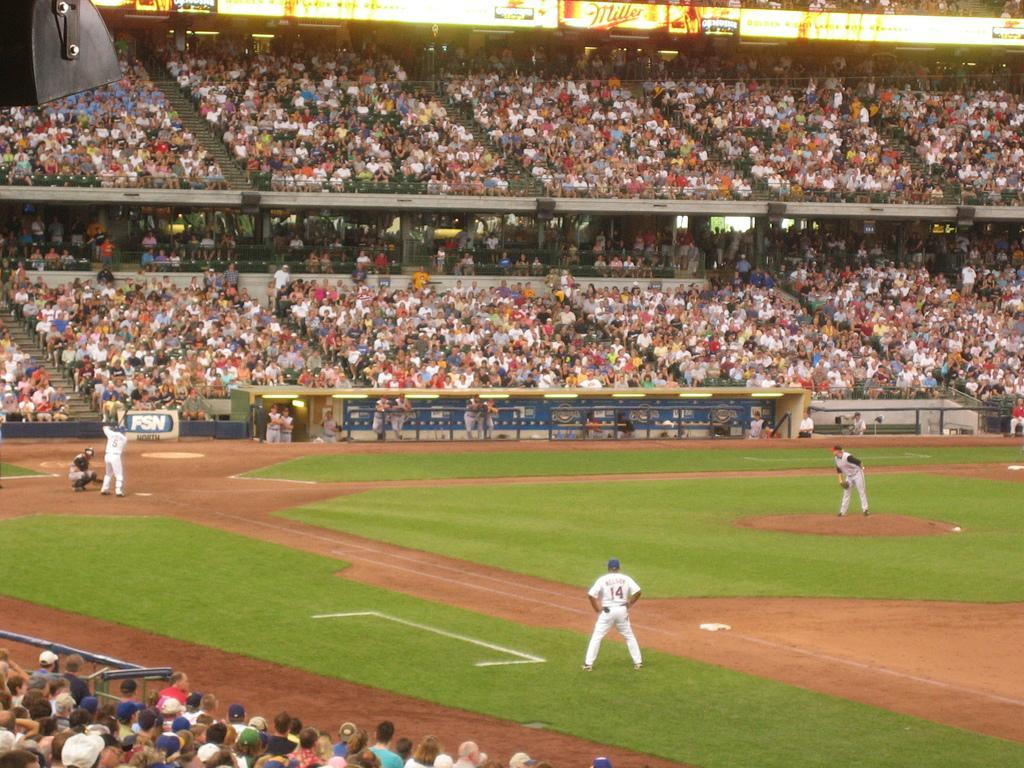Can you describe this image briefly? In this image we can see a few people, some of them are playing baseball, some of them are sitting on the seats, there are boards with text on them, there are railings, there is an object on the left top corner of the image. 